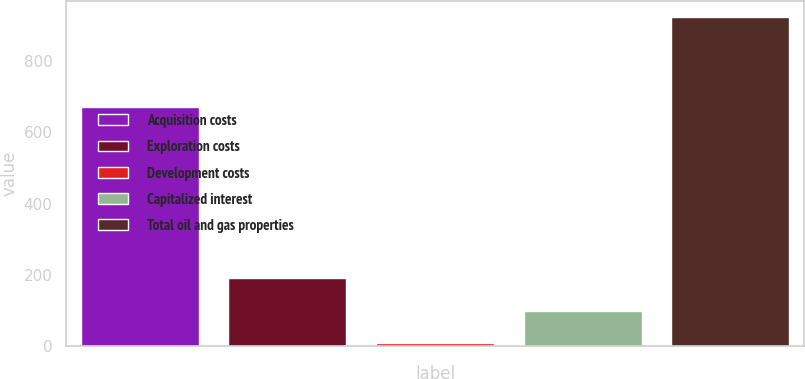Convert chart to OTSL. <chart><loc_0><loc_0><loc_500><loc_500><bar_chart><fcel>Acquisition costs<fcel>Exploration costs<fcel>Development costs<fcel>Capitalized interest<fcel>Total oil and gas properties<nl><fcel>672<fcel>191.6<fcel>9<fcel>100.3<fcel>922<nl></chart> 